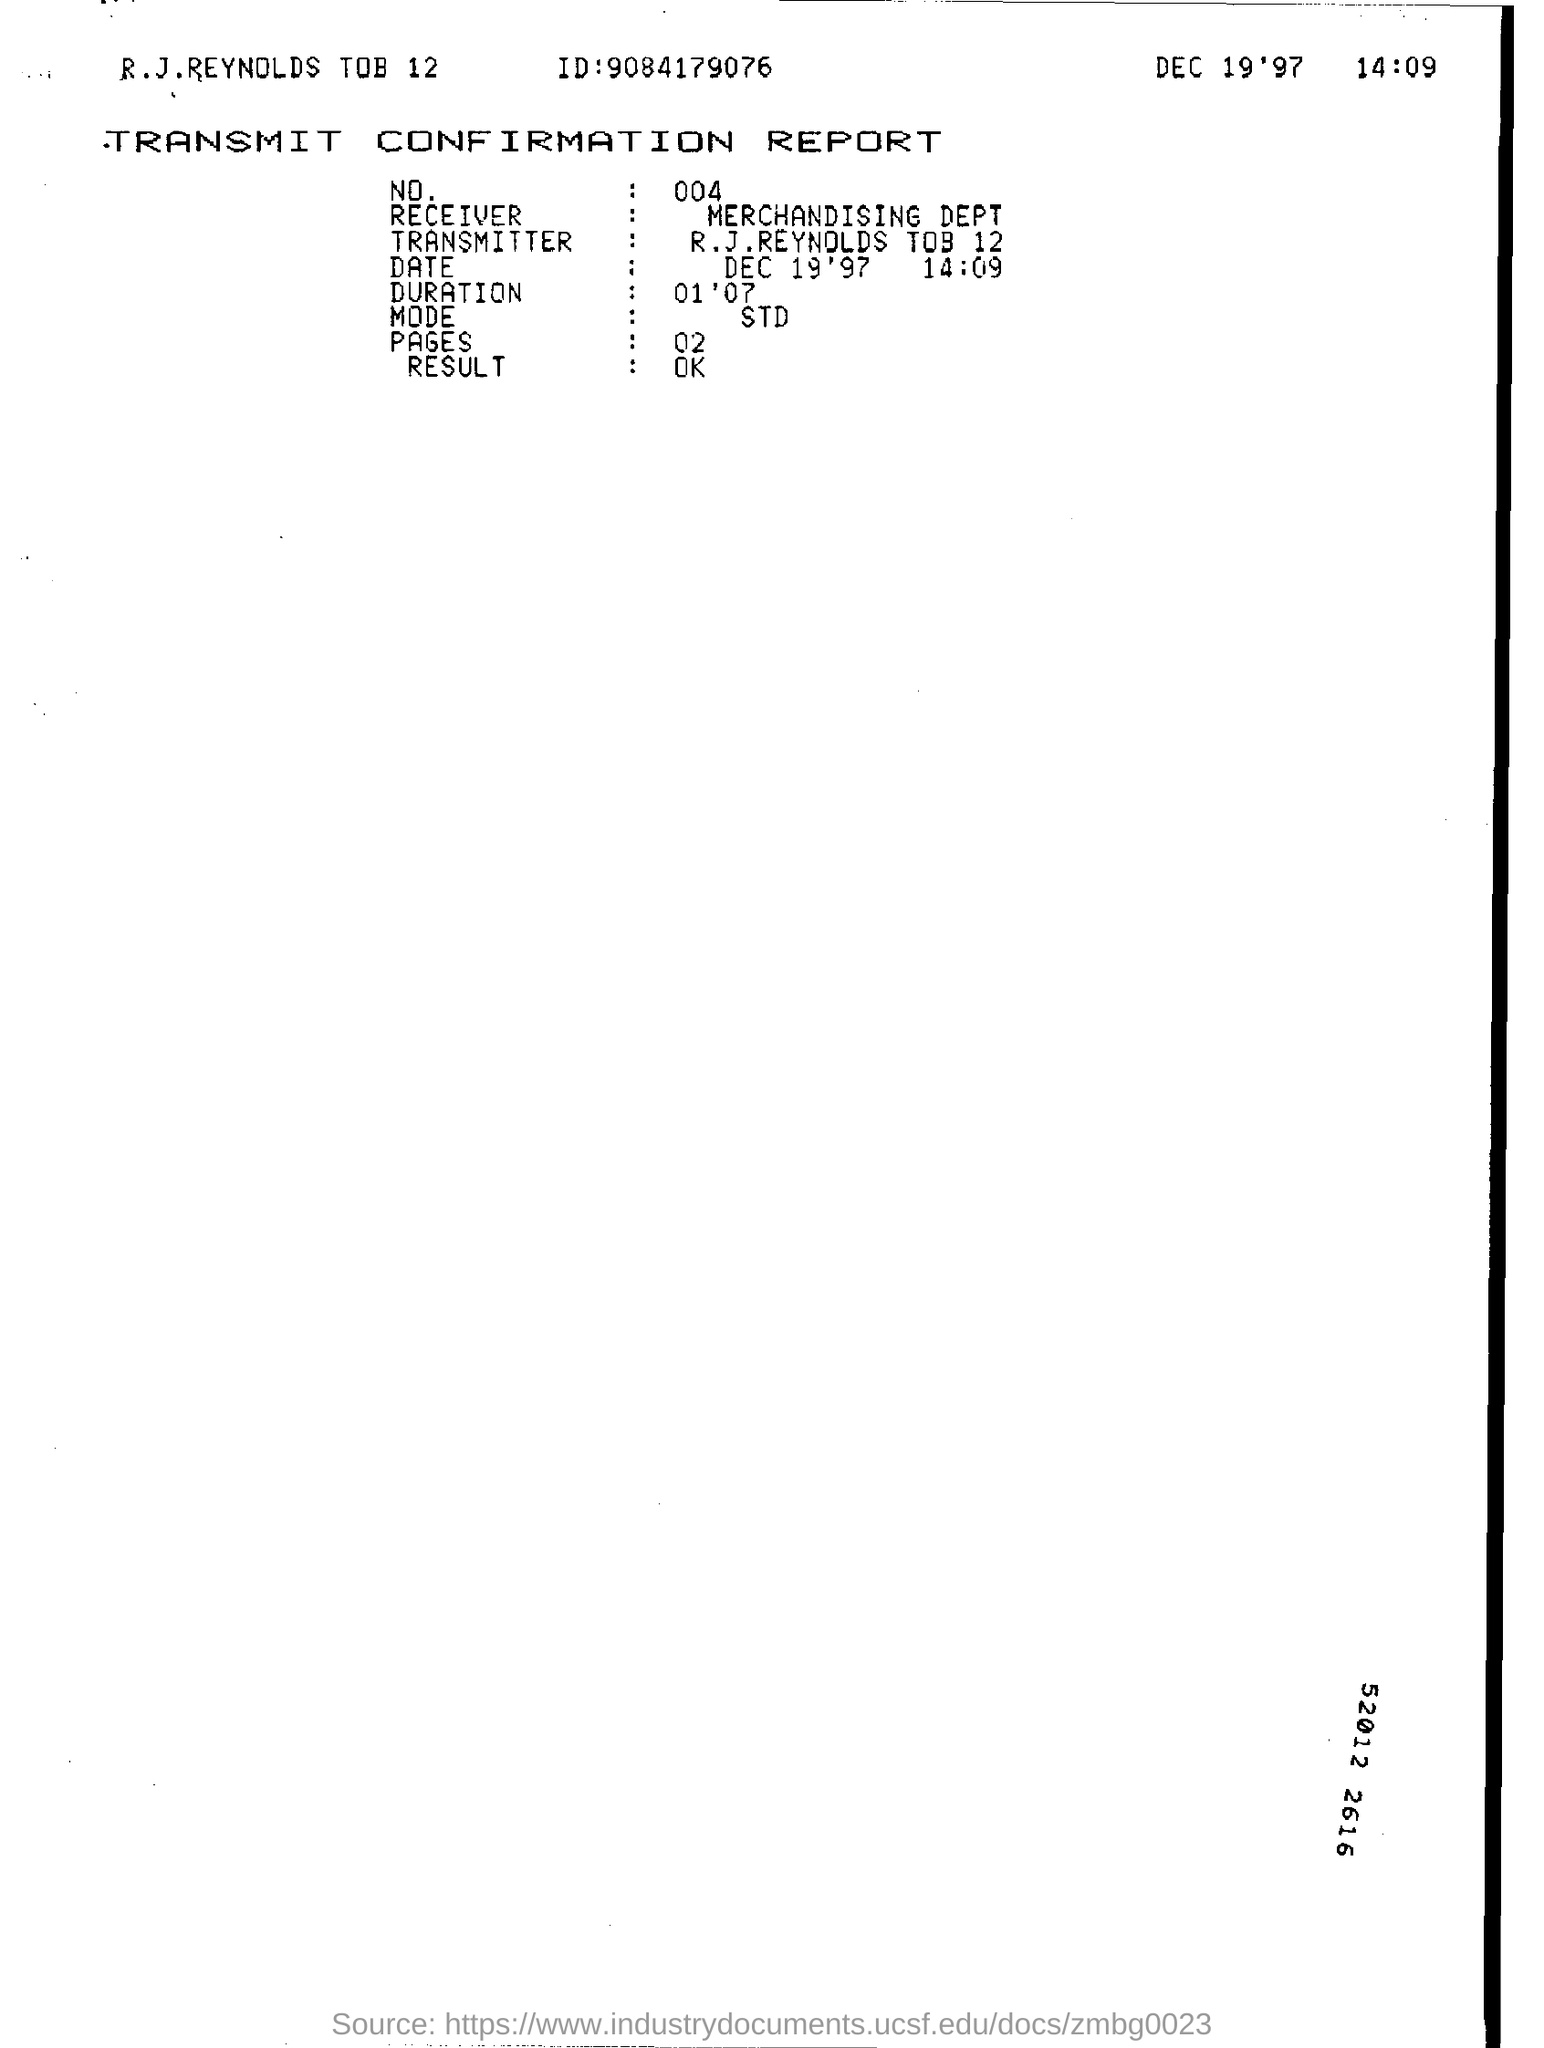What is ID Number ?
Make the answer very short. 9084179076. Who is the Receiver ?
Keep it short and to the point. MERCHANDISING DEPT. How many pages are there?
Provide a succinct answer. 02. 